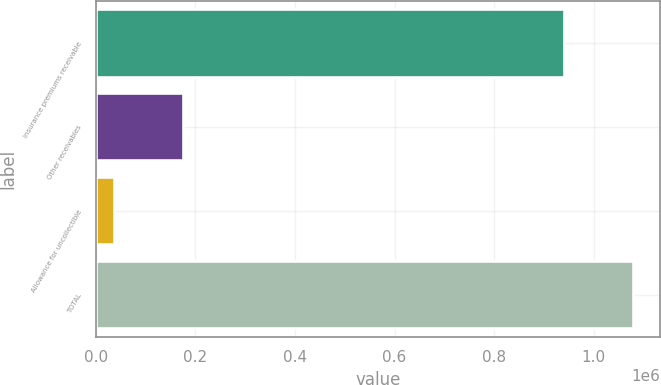Convert chart to OTSL. <chart><loc_0><loc_0><loc_500><loc_500><bar_chart><fcel>Insurance premiums receivable<fcel>Other receivables<fcel>Allowance for uncollectible<fcel>TOTAL<nl><fcel>941460<fcel>175357<fcel>36646<fcel>1.08017e+06<nl></chart> 